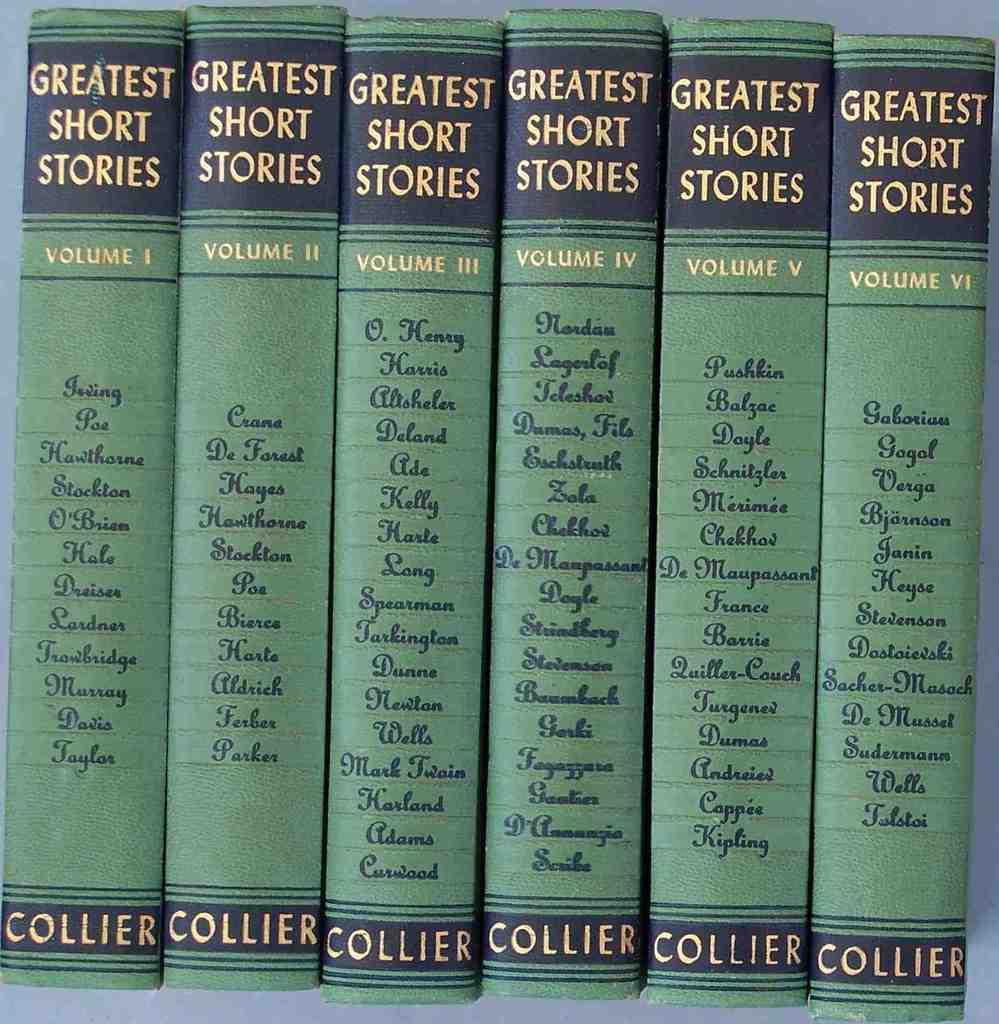Who is the author?
Offer a terse response. Collier. 